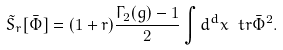<formula> <loc_0><loc_0><loc_500><loc_500>\tilde { S } _ { r } [ \bar { \Phi } ] = ( 1 + r ) \frac { \Gamma _ { 2 } ( g ) - 1 } { 2 } \int { d ^ { d } x } \ t r \bar { \Phi } ^ { 2 } .</formula> 